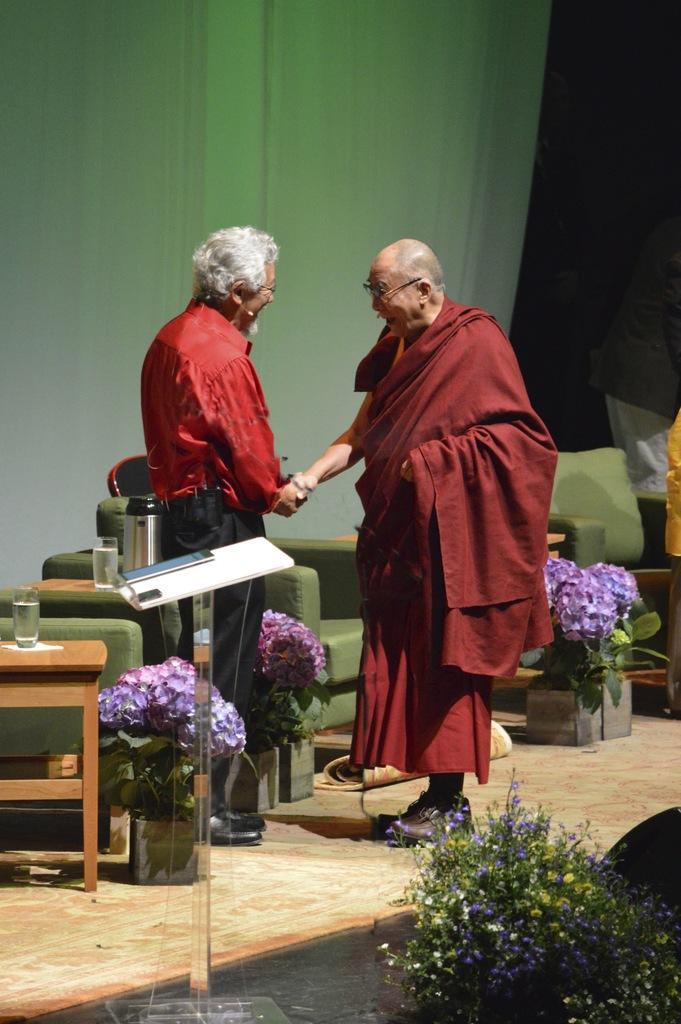How would you summarize this image in a sentence or two? This is the picture of a two person standing on a floor. Background of this people there are table and chairs and a wall. 